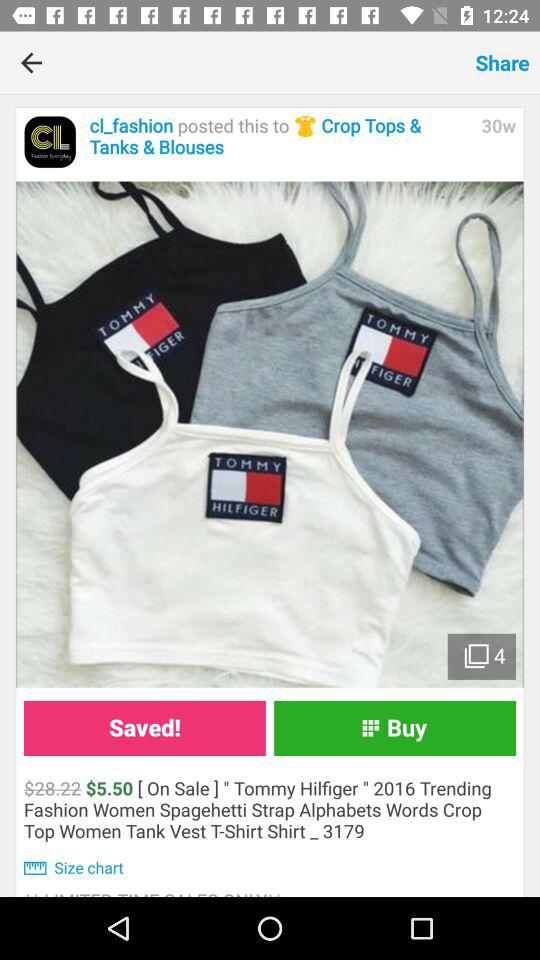What is the total number of given images? The total number of given images is 4. 